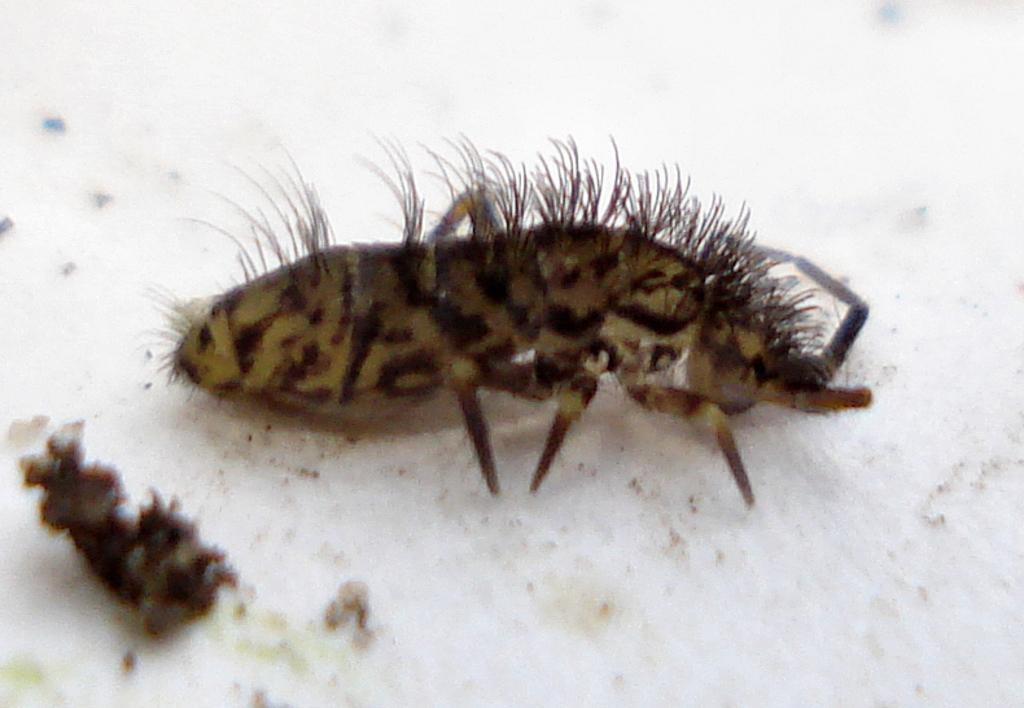Describe this image in one or two sentences. In the picture we can see an insect on the white color surface, and to the insect we can see some hair and legs, and near it we can see some dust particles. 